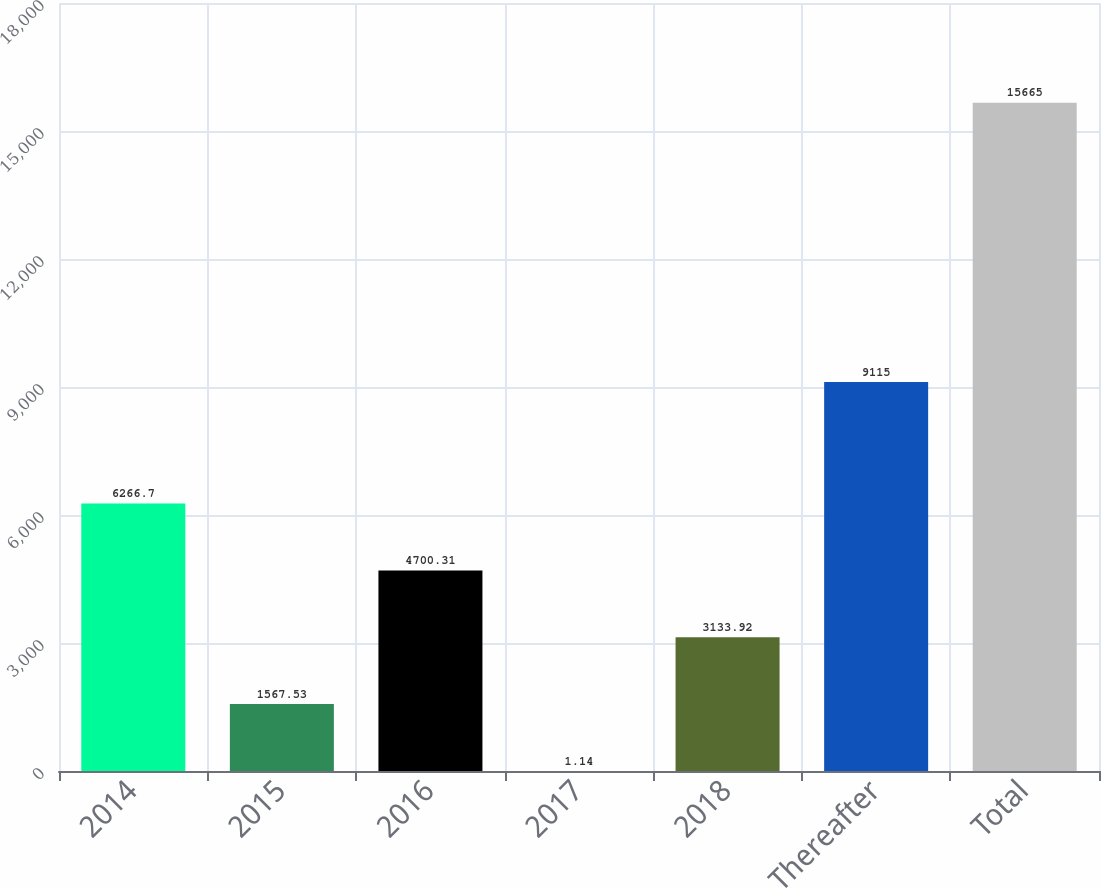Convert chart to OTSL. <chart><loc_0><loc_0><loc_500><loc_500><bar_chart><fcel>2014<fcel>2015<fcel>2016<fcel>2017<fcel>2018<fcel>Thereafter<fcel>Total<nl><fcel>6266.7<fcel>1567.53<fcel>4700.31<fcel>1.14<fcel>3133.92<fcel>9115<fcel>15665<nl></chart> 